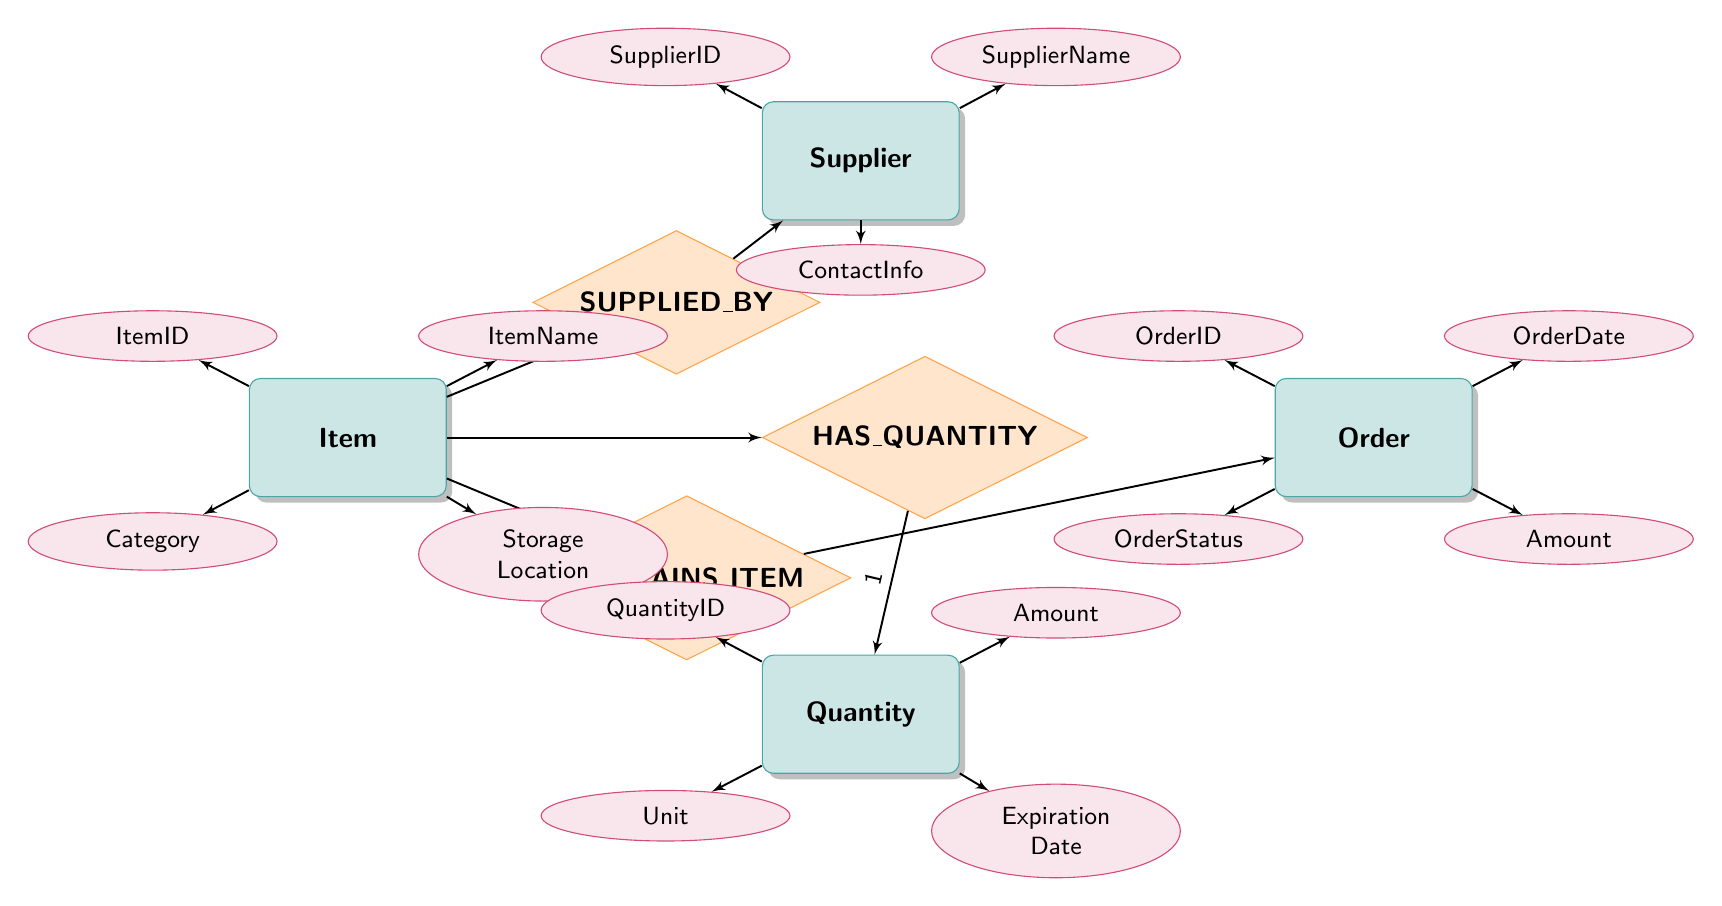What is the primary entity in the diagram? The primary entity in the diagram is "Item," as it is the central focus of the relationships and has multiple linked entities.
Answer: Item How many attributes are associated with the "Quantity" entity? The "Quantity" entity has four attributes listed: QuantityID, Amount, Unit, and ExpirationDate, which counts as four.
Answer: 4 What relationship connects "Item" and "Quantity"? The relationship that connects "Item" and "Quantity" is called "HAS_QUANTITY," which indicates that an item can have multiple quantities.
Answer: HAS_QUANTITY Which entities have a many-to-many relationship? The entities with a many-to-many relationship are "Item" and "Supplier," as well as "Order" and "Item," indicating that multiple items can be supplied by multiple suppliers and multiple items can be part of one order.
Answer: Item and Supplier; Order and Item What is the cardinality of the relationship between "Item" and "Quantity"? The cardinality of the relationship between "Item" and "Quantity" is "1-to-Many," meaning each item can have multiple quantities associated with it.
Answer: 1-to-Many What does the "SUPPLIED_BY" relationship represent? The "SUPPLIED_BY" relationship represents that multiple items can be supplied by multiple suppliers, allowing for various sources for any given item.
Answer: Many-to-Many How many entities are in the diagram? There are four entities in the diagram: Item, Quantity, Supplier, and Order, which makes the total count four.
Answer: 4 Which entity is linked to the "Order" entity? The "Order" entity is linked to the "Item" entity through the "CONTAINS_ITEM" relationship, showing that orders comprise one or more items.
Answer: Item 